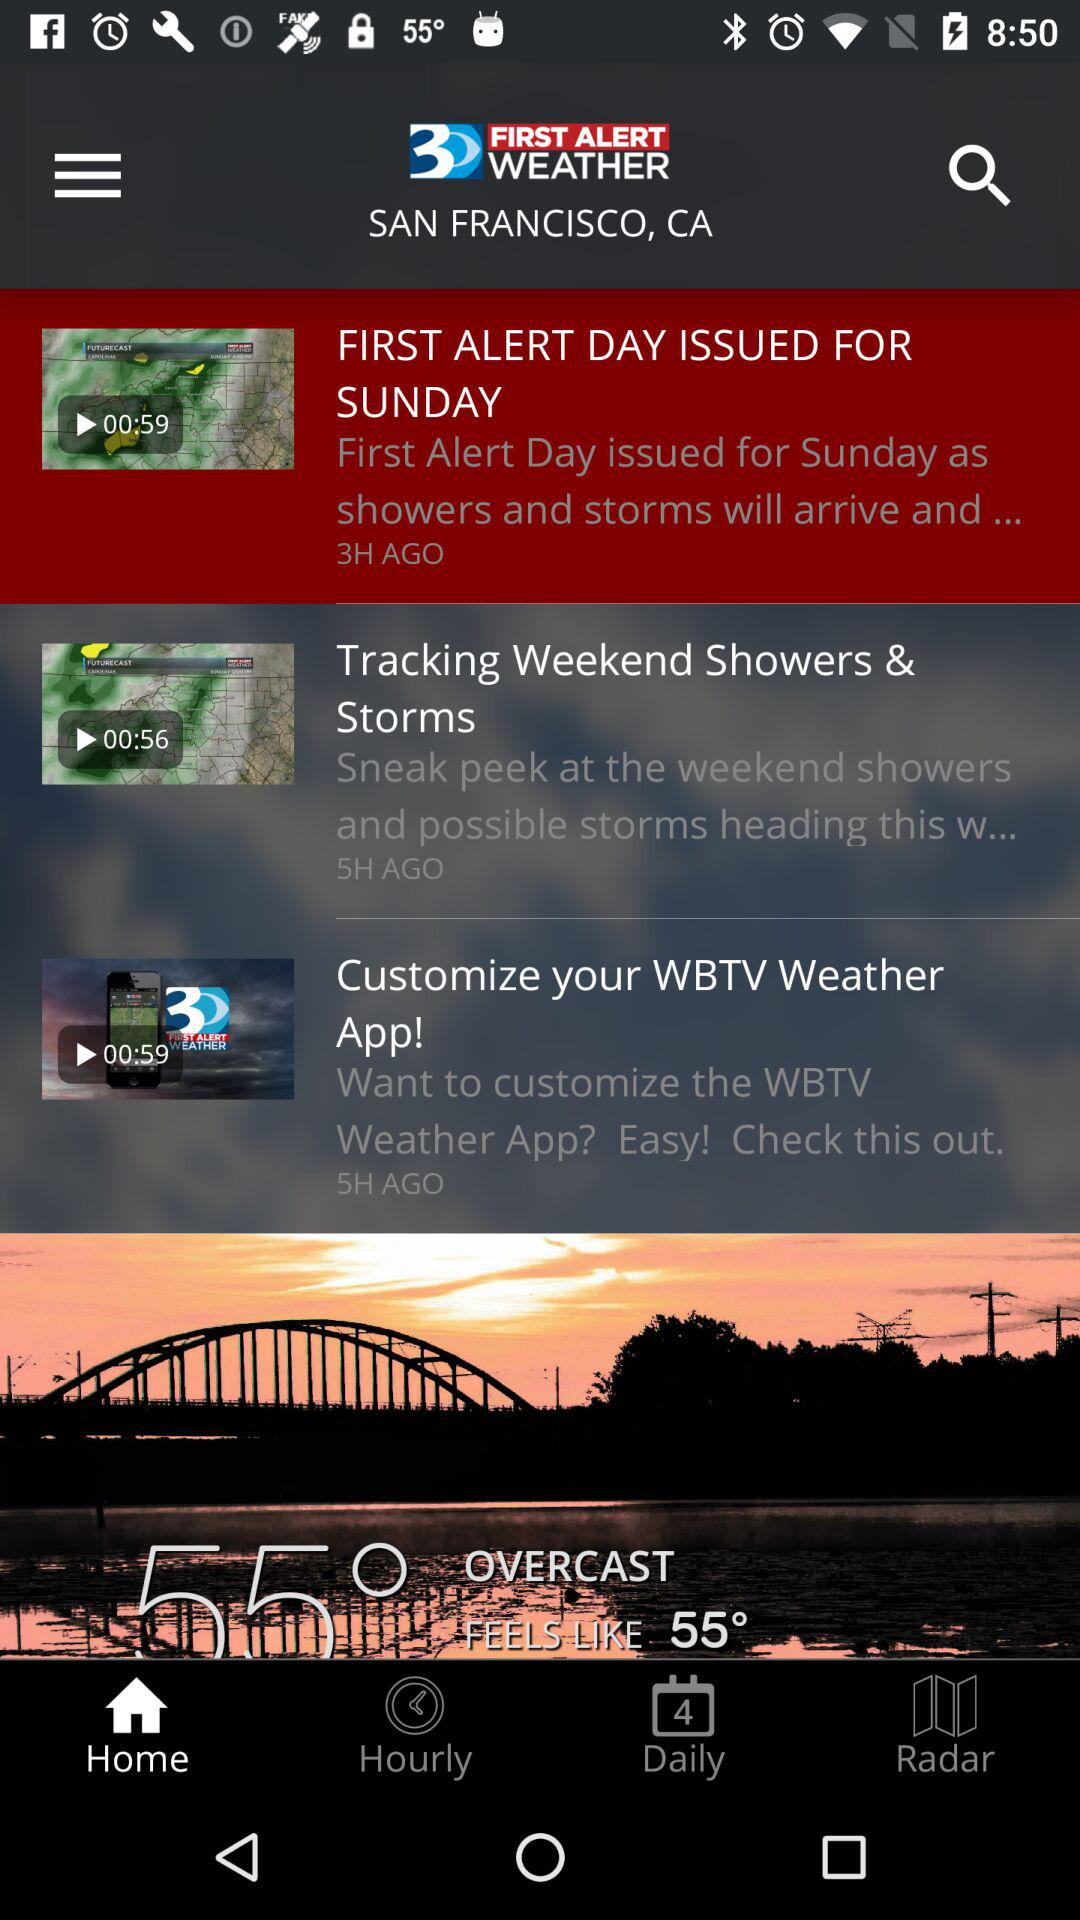How many hours ago was the first alert day issued?
Answer the question using a single word or phrase. 3 